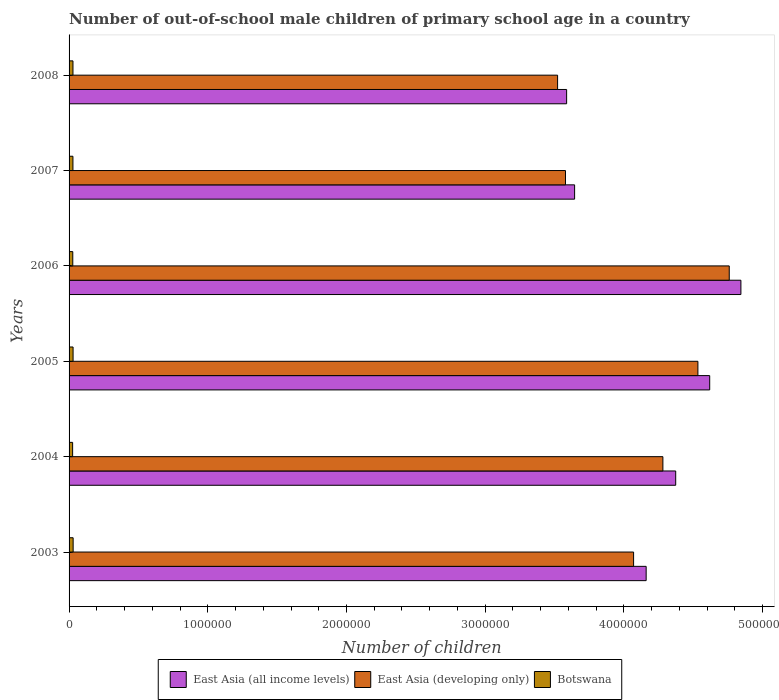How many different coloured bars are there?
Provide a succinct answer. 3. How many groups of bars are there?
Give a very brief answer. 6. Are the number of bars on each tick of the Y-axis equal?
Offer a very short reply. Yes. What is the label of the 4th group of bars from the top?
Keep it short and to the point. 2005. What is the number of out-of-school male children in Botswana in 2008?
Ensure brevity in your answer.  2.81e+04. Across all years, what is the maximum number of out-of-school male children in East Asia (all income levels)?
Your response must be concise. 4.84e+06. Across all years, what is the minimum number of out-of-school male children in East Asia (all income levels)?
Keep it short and to the point. 3.59e+06. What is the total number of out-of-school male children in Botswana in the graph?
Keep it short and to the point. 1.66e+05. What is the difference between the number of out-of-school male children in East Asia (all income levels) in 2003 and that in 2005?
Provide a succinct answer. -4.58e+05. What is the difference between the number of out-of-school male children in Botswana in 2008 and the number of out-of-school male children in East Asia (developing only) in 2003?
Your response must be concise. -4.04e+06. What is the average number of out-of-school male children in Botswana per year?
Keep it short and to the point. 2.77e+04. In the year 2008, what is the difference between the number of out-of-school male children in East Asia (developing only) and number of out-of-school male children in East Asia (all income levels)?
Make the answer very short. -6.50e+04. In how many years, is the number of out-of-school male children in East Asia (all income levels) greater than 4800000 ?
Offer a terse response. 1. What is the ratio of the number of out-of-school male children in East Asia (developing only) in 2007 to that in 2008?
Ensure brevity in your answer.  1.02. Is the number of out-of-school male children in East Asia (developing only) in 2003 less than that in 2008?
Provide a short and direct response. No. What is the difference between the highest and the second highest number of out-of-school male children in Botswana?
Offer a terse response. 468. What is the difference between the highest and the lowest number of out-of-school male children in East Asia (all income levels)?
Your response must be concise. 1.26e+06. In how many years, is the number of out-of-school male children in Botswana greater than the average number of out-of-school male children in Botswana taken over all years?
Your response must be concise. 4. What does the 2nd bar from the top in 2003 represents?
Keep it short and to the point. East Asia (developing only). What does the 2nd bar from the bottom in 2007 represents?
Provide a short and direct response. East Asia (developing only). Is it the case that in every year, the sum of the number of out-of-school male children in East Asia (developing only) and number of out-of-school male children in Botswana is greater than the number of out-of-school male children in East Asia (all income levels)?
Give a very brief answer. No. What is the difference between two consecutive major ticks on the X-axis?
Offer a very short reply. 1.00e+06. What is the title of the graph?
Your answer should be very brief. Number of out-of-school male children of primary school age in a country. What is the label or title of the X-axis?
Provide a short and direct response. Number of children. What is the Number of children of East Asia (all income levels) in 2003?
Make the answer very short. 4.16e+06. What is the Number of children of East Asia (developing only) in 2003?
Provide a short and direct response. 4.07e+06. What is the Number of children of Botswana in 2003?
Offer a terse response. 2.93e+04. What is the Number of children in East Asia (all income levels) in 2004?
Provide a short and direct response. 4.37e+06. What is the Number of children in East Asia (developing only) in 2004?
Offer a very short reply. 4.28e+06. What is the Number of children in Botswana in 2004?
Your answer should be very brief. 2.56e+04. What is the Number of children in East Asia (all income levels) in 2005?
Provide a short and direct response. 4.62e+06. What is the Number of children of East Asia (developing only) in 2005?
Provide a short and direct response. 4.53e+06. What is the Number of children in Botswana in 2005?
Your response must be concise. 2.88e+04. What is the Number of children in East Asia (all income levels) in 2006?
Make the answer very short. 4.84e+06. What is the Number of children in East Asia (developing only) in 2006?
Give a very brief answer. 4.76e+06. What is the Number of children of Botswana in 2006?
Your response must be concise. 2.67e+04. What is the Number of children of East Asia (all income levels) in 2007?
Your response must be concise. 3.64e+06. What is the Number of children of East Asia (developing only) in 2007?
Provide a succinct answer. 3.58e+06. What is the Number of children in Botswana in 2007?
Make the answer very short. 2.78e+04. What is the Number of children of East Asia (all income levels) in 2008?
Ensure brevity in your answer.  3.59e+06. What is the Number of children in East Asia (developing only) in 2008?
Provide a succinct answer. 3.52e+06. What is the Number of children in Botswana in 2008?
Offer a terse response. 2.81e+04. Across all years, what is the maximum Number of children in East Asia (all income levels)?
Give a very brief answer. 4.84e+06. Across all years, what is the maximum Number of children of East Asia (developing only)?
Make the answer very short. 4.76e+06. Across all years, what is the maximum Number of children in Botswana?
Your response must be concise. 2.93e+04. Across all years, what is the minimum Number of children of East Asia (all income levels)?
Provide a short and direct response. 3.59e+06. Across all years, what is the minimum Number of children in East Asia (developing only)?
Ensure brevity in your answer.  3.52e+06. Across all years, what is the minimum Number of children of Botswana?
Keep it short and to the point. 2.56e+04. What is the total Number of children in East Asia (all income levels) in the graph?
Your answer should be compact. 2.52e+07. What is the total Number of children of East Asia (developing only) in the graph?
Ensure brevity in your answer.  2.47e+07. What is the total Number of children of Botswana in the graph?
Offer a terse response. 1.66e+05. What is the difference between the Number of children in East Asia (all income levels) in 2003 and that in 2004?
Ensure brevity in your answer.  -2.13e+05. What is the difference between the Number of children of East Asia (developing only) in 2003 and that in 2004?
Your response must be concise. -2.11e+05. What is the difference between the Number of children in Botswana in 2003 and that in 2004?
Make the answer very short. 3717. What is the difference between the Number of children of East Asia (all income levels) in 2003 and that in 2005?
Offer a terse response. -4.58e+05. What is the difference between the Number of children of East Asia (developing only) in 2003 and that in 2005?
Give a very brief answer. -4.64e+05. What is the difference between the Number of children in Botswana in 2003 and that in 2005?
Keep it short and to the point. 468. What is the difference between the Number of children of East Asia (all income levels) in 2003 and that in 2006?
Your response must be concise. -6.83e+05. What is the difference between the Number of children of East Asia (developing only) in 2003 and that in 2006?
Offer a terse response. -6.90e+05. What is the difference between the Number of children of Botswana in 2003 and that in 2006?
Make the answer very short. 2620. What is the difference between the Number of children of East Asia (all income levels) in 2003 and that in 2007?
Keep it short and to the point. 5.16e+05. What is the difference between the Number of children of East Asia (developing only) in 2003 and that in 2007?
Your response must be concise. 4.91e+05. What is the difference between the Number of children of Botswana in 2003 and that in 2007?
Your answer should be compact. 1478. What is the difference between the Number of children in East Asia (all income levels) in 2003 and that in 2008?
Your response must be concise. 5.73e+05. What is the difference between the Number of children of East Asia (developing only) in 2003 and that in 2008?
Your answer should be very brief. 5.48e+05. What is the difference between the Number of children in Botswana in 2003 and that in 2008?
Provide a short and direct response. 1226. What is the difference between the Number of children in East Asia (all income levels) in 2004 and that in 2005?
Make the answer very short. -2.45e+05. What is the difference between the Number of children of East Asia (developing only) in 2004 and that in 2005?
Ensure brevity in your answer.  -2.53e+05. What is the difference between the Number of children in Botswana in 2004 and that in 2005?
Offer a very short reply. -3249. What is the difference between the Number of children of East Asia (all income levels) in 2004 and that in 2006?
Your response must be concise. -4.70e+05. What is the difference between the Number of children in East Asia (developing only) in 2004 and that in 2006?
Your answer should be compact. -4.78e+05. What is the difference between the Number of children in Botswana in 2004 and that in 2006?
Provide a succinct answer. -1097. What is the difference between the Number of children in East Asia (all income levels) in 2004 and that in 2007?
Give a very brief answer. 7.29e+05. What is the difference between the Number of children of East Asia (developing only) in 2004 and that in 2007?
Provide a succinct answer. 7.02e+05. What is the difference between the Number of children in Botswana in 2004 and that in 2007?
Keep it short and to the point. -2239. What is the difference between the Number of children of East Asia (all income levels) in 2004 and that in 2008?
Your answer should be compact. 7.86e+05. What is the difference between the Number of children of East Asia (developing only) in 2004 and that in 2008?
Your answer should be very brief. 7.59e+05. What is the difference between the Number of children in Botswana in 2004 and that in 2008?
Provide a succinct answer. -2491. What is the difference between the Number of children of East Asia (all income levels) in 2005 and that in 2006?
Offer a terse response. -2.25e+05. What is the difference between the Number of children of East Asia (developing only) in 2005 and that in 2006?
Your answer should be very brief. -2.26e+05. What is the difference between the Number of children of Botswana in 2005 and that in 2006?
Offer a very short reply. 2152. What is the difference between the Number of children of East Asia (all income levels) in 2005 and that in 2007?
Your answer should be very brief. 9.74e+05. What is the difference between the Number of children in East Asia (developing only) in 2005 and that in 2007?
Offer a terse response. 9.55e+05. What is the difference between the Number of children of Botswana in 2005 and that in 2007?
Provide a succinct answer. 1010. What is the difference between the Number of children in East Asia (all income levels) in 2005 and that in 2008?
Offer a very short reply. 1.03e+06. What is the difference between the Number of children in East Asia (developing only) in 2005 and that in 2008?
Provide a succinct answer. 1.01e+06. What is the difference between the Number of children of Botswana in 2005 and that in 2008?
Keep it short and to the point. 758. What is the difference between the Number of children of East Asia (all income levels) in 2006 and that in 2007?
Offer a terse response. 1.20e+06. What is the difference between the Number of children of East Asia (developing only) in 2006 and that in 2007?
Give a very brief answer. 1.18e+06. What is the difference between the Number of children in Botswana in 2006 and that in 2007?
Your response must be concise. -1142. What is the difference between the Number of children of East Asia (all income levels) in 2006 and that in 2008?
Make the answer very short. 1.26e+06. What is the difference between the Number of children of East Asia (developing only) in 2006 and that in 2008?
Provide a succinct answer. 1.24e+06. What is the difference between the Number of children in Botswana in 2006 and that in 2008?
Provide a short and direct response. -1394. What is the difference between the Number of children of East Asia (all income levels) in 2007 and that in 2008?
Offer a very short reply. 5.76e+04. What is the difference between the Number of children of East Asia (developing only) in 2007 and that in 2008?
Give a very brief answer. 5.68e+04. What is the difference between the Number of children of Botswana in 2007 and that in 2008?
Your answer should be compact. -252. What is the difference between the Number of children of East Asia (all income levels) in 2003 and the Number of children of East Asia (developing only) in 2004?
Offer a terse response. -1.21e+05. What is the difference between the Number of children of East Asia (all income levels) in 2003 and the Number of children of Botswana in 2004?
Your answer should be very brief. 4.13e+06. What is the difference between the Number of children of East Asia (developing only) in 2003 and the Number of children of Botswana in 2004?
Your answer should be very brief. 4.04e+06. What is the difference between the Number of children in East Asia (all income levels) in 2003 and the Number of children in East Asia (developing only) in 2005?
Give a very brief answer. -3.73e+05. What is the difference between the Number of children in East Asia (all income levels) in 2003 and the Number of children in Botswana in 2005?
Provide a short and direct response. 4.13e+06. What is the difference between the Number of children in East Asia (developing only) in 2003 and the Number of children in Botswana in 2005?
Ensure brevity in your answer.  4.04e+06. What is the difference between the Number of children in East Asia (all income levels) in 2003 and the Number of children in East Asia (developing only) in 2006?
Offer a terse response. -5.99e+05. What is the difference between the Number of children of East Asia (all income levels) in 2003 and the Number of children of Botswana in 2006?
Offer a very short reply. 4.13e+06. What is the difference between the Number of children of East Asia (developing only) in 2003 and the Number of children of Botswana in 2006?
Provide a succinct answer. 4.04e+06. What is the difference between the Number of children of East Asia (all income levels) in 2003 and the Number of children of East Asia (developing only) in 2007?
Provide a short and direct response. 5.82e+05. What is the difference between the Number of children of East Asia (all income levels) in 2003 and the Number of children of Botswana in 2007?
Give a very brief answer. 4.13e+06. What is the difference between the Number of children of East Asia (developing only) in 2003 and the Number of children of Botswana in 2007?
Make the answer very short. 4.04e+06. What is the difference between the Number of children in East Asia (all income levels) in 2003 and the Number of children in East Asia (developing only) in 2008?
Your response must be concise. 6.38e+05. What is the difference between the Number of children of East Asia (all income levels) in 2003 and the Number of children of Botswana in 2008?
Offer a terse response. 4.13e+06. What is the difference between the Number of children in East Asia (developing only) in 2003 and the Number of children in Botswana in 2008?
Offer a very short reply. 4.04e+06. What is the difference between the Number of children of East Asia (all income levels) in 2004 and the Number of children of East Asia (developing only) in 2005?
Your answer should be very brief. -1.60e+05. What is the difference between the Number of children in East Asia (all income levels) in 2004 and the Number of children in Botswana in 2005?
Make the answer very short. 4.34e+06. What is the difference between the Number of children of East Asia (developing only) in 2004 and the Number of children of Botswana in 2005?
Offer a terse response. 4.25e+06. What is the difference between the Number of children in East Asia (all income levels) in 2004 and the Number of children in East Asia (developing only) in 2006?
Your answer should be compact. -3.86e+05. What is the difference between the Number of children of East Asia (all income levels) in 2004 and the Number of children of Botswana in 2006?
Ensure brevity in your answer.  4.35e+06. What is the difference between the Number of children in East Asia (developing only) in 2004 and the Number of children in Botswana in 2006?
Provide a short and direct response. 4.25e+06. What is the difference between the Number of children of East Asia (all income levels) in 2004 and the Number of children of East Asia (developing only) in 2007?
Your answer should be compact. 7.95e+05. What is the difference between the Number of children in East Asia (all income levels) in 2004 and the Number of children in Botswana in 2007?
Your response must be concise. 4.35e+06. What is the difference between the Number of children of East Asia (developing only) in 2004 and the Number of children of Botswana in 2007?
Offer a terse response. 4.25e+06. What is the difference between the Number of children in East Asia (all income levels) in 2004 and the Number of children in East Asia (developing only) in 2008?
Offer a very short reply. 8.51e+05. What is the difference between the Number of children of East Asia (all income levels) in 2004 and the Number of children of Botswana in 2008?
Give a very brief answer. 4.35e+06. What is the difference between the Number of children in East Asia (developing only) in 2004 and the Number of children in Botswana in 2008?
Make the answer very short. 4.25e+06. What is the difference between the Number of children in East Asia (all income levels) in 2005 and the Number of children in East Asia (developing only) in 2006?
Your answer should be compact. -1.41e+05. What is the difference between the Number of children in East Asia (all income levels) in 2005 and the Number of children in Botswana in 2006?
Your answer should be very brief. 4.59e+06. What is the difference between the Number of children of East Asia (developing only) in 2005 and the Number of children of Botswana in 2006?
Provide a short and direct response. 4.51e+06. What is the difference between the Number of children in East Asia (all income levels) in 2005 and the Number of children in East Asia (developing only) in 2007?
Give a very brief answer. 1.04e+06. What is the difference between the Number of children of East Asia (all income levels) in 2005 and the Number of children of Botswana in 2007?
Make the answer very short. 4.59e+06. What is the difference between the Number of children in East Asia (developing only) in 2005 and the Number of children in Botswana in 2007?
Your response must be concise. 4.51e+06. What is the difference between the Number of children of East Asia (all income levels) in 2005 and the Number of children of East Asia (developing only) in 2008?
Ensure brevity in your answer.  1.10e+06. What is the difference between the Number of children of East Asia (all income levels) in 2005 and the Number of children of Botswana in 2008?
Provide a short and direct response. 4.59e+06. What is the difference between the Number of children in East Asia (developing only) in 2005 and the Number of children in Botswana in 2008?
Your answer should be very brief. 4.51e+06. What is the difference between the Number of children in East Asia (all income levels) in 2006 and the Number of children in East Asia (developing only) in 2007?
Offer a terse response. 1.26e+06. What is the difference between the Number of children of East Asia (all income levels) in 2006 and the Number of children of Botswana in 2007?
Provide a succinct answer. 4.82e+06. What is the difference between the Number of children of East Asia (developing only) in 2006 and the Number of children of Botswana in 2007?
Offer a terse response. 4.73e+06. What is the difference between the Number of children in East Asia (all income levels) in 2006 and the Number of children in East Asia (developing only) in 2008?
Provide a short and direct response. 1.32e+06. What is the difference between the Number of children of East Asia (all income levels) in 2006 and the Number of children of Botswana in 2008?
Your answer should be very brief. 4.82e+06. What is the difference between the Number of children of East Asia (developing only) in 2006 and the Number of children of Botswana in 2008?
Offer a very short reply. 4.73e+06. What is the difference between the Number of children of East Asia (all income levels) in 2007 and the Number of children of East Asia (developing only) in 2008?
Your answer should be compact. 1.23e+05. What is the difference between the Number of children of East Asia (all income levels) in 2007 and the Number of children of Botswana in 2008?
Ensure brevity in your answer.  3.62e+06. What is the difference between the Number of children of East Asia (developing only) in 2007 and the Number of children of Botswana in 2008?
Your response must be concise. 3.55e+06. What is the average Number of children in East Asia (all income levels) per year?
Give a very brief answer. 4.20e+06. What is the average Number of children of East Asia (developing only) per year?
Ensure brevity in your answer.  4.12e+06. What is the average Number of children of Botswana per year?
Give a very brief answer. 2.77e+04. In the year 2003, what is the difference between the Number of children in East Asia (all income levels) and Number of children in East Asia (developing only)?
Make the answer very short. 9.06e+04. In the year 2003, what is the difference between the Number of children of East Asia (all income levels) and Number of children of Botswana?
Offer a very short reply. 4.13e+06. In the year 2003, what is the difference between the Number of children of East Asia (developing only) and Number of children of Botswana?
Offer a terse response. 4.04e+06. In the year 2004, what is the difference between the Number of children of East Asia (all income levels) and Number of children of East Asia (developing only)?
Offer a terse response. 9.24e+04. In the year 2004, what is the difference between the Number of children of East Asia (all income levels) and Number of children of Botswana?
Your answer should be very brief. 4.35e+06. In the year 2004, what is the difference between the Number of children in East Asia (developing only) and Number of children in Botswana?
Offer a terse response. 4.26e+06. In the year 2005, what is the difference between the Number of children in East Asia (all income levels) and Number of children in East Asia (developing only)?
Your answer should be very brief. 8.50e+04. In the year 2005, what is the difference between the Number of children in East Asia (all income levels) and Number of children in Botswana?
Offer a very short reply. 4.59e+06. In the year 2005, what is the difference between the Number of children in East Asia (developing only) and Number of children in Botswana?
Provide a short and direct response. 4.50e+06. In the year 2006, what is the difference between the Number of children of East Asia (all income levels) and Number of children of East Asia (developing only)?
Offer a terse response. 8.40e+04. In the year 2006, what is the difference between the Number of children of East Asia (all income levels) and Number of children of Botswana?
Provide a short and direct response. 4.82e+06. In the year 2006, what is the difference between the Number of children in East Asia (developing only) and Number of children in Botswana?
Provide a short and direct response. 4.73e+06. In the year 2007, what is the difference between the Number of children in East Asia (all income levels) and Number of children in East Asia (developing only)?
Make the answer very short. 6.58e+04. In the year 2007, what is the difference between the Number of children in East Asia (all income levels) and Number of children in Botswana?
Your answer should be compact. 3.62e+06. In the year 2007, what is the difference between the Number of children in East Asia (developing only) and Number of children in Botswana?
Ensure brevity in your answer.  3.55e+06. In the year 2008, what is the difference between the Number of children of East Asia (all income levels) and Number of children of East Asia (developing only)?
Give a very brief answer. 6.50e+04. In the year 2008, what is the difference between the Number of children of East Asia (all income levels) and Number of children of Botswana?
Your response must be concise. 3.56e+06. In the year 2008, what is the difference between the Number of children of East Asia (developing only) and Number of children of Botswana?
Keep it short and to the point. 3.49e+06. What is the ratio of the Number of children in East Asia (all income levels) in 2003 to that in 2004?
Offer a terse response. 0.95. What is the ratio of the Number of children of East Asia (developing only) in 2003 to that in 2004?
Provide a succinct answer. 0.95. What is the ratio of the Number of children in Botswana in 2003 to that in 2004?
Offer a terse response. 1.15. What is the ratio of the Number of children of East Asia (all income levels) in 2003 to that in 2005?
Your answer should be compact. 0.9. What is the ratio of the Number of children of East Asia (developing only) in 2003 to that in 2005?
Keep it short and to the point. 0.9. What is the ratio of the Number of children in Botswana in 2003 to that in 2005?
Your response must be concise. 1.02. What is the ratio of the Number of children in East Asia (all income levels) in 2003 to that in 2006?
Make the answer very short. 0.86. What is the ratio of the Number of children in East Asia (developing only) in 2003 to that in 2006?
Provide a short and direct response. 0.86. What is the ratio of the Number of children in Botswana in 2003 to that in 2006?
Your response must be concise. 1.1. What is the ratio of the Number of children in East Asia (all income levels) in 2003 to that in 2007?
Provide a succinct answer. 1.14. What is the ratio of the Number of children of East Asia (developing only) in 2003 to that in 2007?
Provide a succinct answer. 1.14. What is the ratio of the Number of children of Botswana in 2003 to that in 2007?
Provide a succinct answer. 1.05. What is the ratio of the Number of children in East Asia (all income levels) in 2003 to that in 2008?
Provide a succinct answer. 1.16. What is the ratio of the Number of children of East Asia (developing only) in 2003 to that in 2008?
Make the answer very short. 1.16. What is the ratio of the Number of children in Botswana in 2003 to that in 2008?
Offer a very short reply. 1.04. What is the ratio of the Number of children in East Asia (all income levels) in 2004 to that in 2005?
Your response must be concise. 0.95. What is the ratio of the Number of children of East Asia (developing only) in 2004 to that in 2005?
Ensure brevity in your answer.  0.94. What is the ratio of the Number of children of Botswana in 2004 to that in 2005?
Your response must be concise. 0.89. What is the ratio of the Number of children in East Asia (all income levels) in 2004 to that in 2006?
Offer a very short reply. 0.9. What is the ratio of the Number of children in East Asia (developing only) in 2004 to that in 2006?
Your response must be concise. 0.9. What is the ratio of the Number of children of Botswana in 2004 to that in 2006?
Make the answer very short. 0.96. What is the ratio of the Number of children in East Asia (developing only) in 2004 to that in 2007?
Offer a very short reply. 1.2. What is the ratio of the Number of children in Botswana in 2004 to that in 2007?
Your answer should be compact. 0.92. What is the ratio of the Number of children in East Asia (all income levels) in 2004 to that in 2008?
Offer a very short reply. 1.22. What is the ratio of the Number of children of East Asia (developing only) in 2004 to that in 2008?
Ensure brevity in your answer.  1.22. What is the ratio of the Number of children in Botswana in 2004 to that in 2008?
Your answer should be compact. 0.91. What is the ratio of the Number of children of East Asia (all income levels) in 2005 to that in 2006?
Keep it short and to the point. 0.95. What is the ratio of the Number of children in East Asia (developing only) in 2005 to that in 2006?
Provide a short and direct response. 0.95. What is the ratio of the Number of children in Botswana in 2005 to that in 2006?
Keep it short and to the point. 1.08. What is the ratio of the Number of children of East Asia (all income levels) in 2005 to that in 2007?
Ensure brevity in your answer.  1.27. What is the ratio of the Number of children in East Asia (developing only) in 2005 to that in 2007?
Keep it short and to the point. 1.27. What is the ratio of the Number of children in Botswana in 2005 to that in 2007?
Your response must be concise. 1.04. What is the ratio of the Number of children of East Asia (all income levels) in 2005 to that in 2008?
Make the answer very short. 1.29. What is the ratio of the Number of children in East Asia (developing only) in 2005 to that in 2008?
Provide a succinct answer. 1.29. What is the ratio of the Number of children of Botswana in 2005 to that in 2008?
Provide a short and direct response. 1.03. What is the ratio of the Number of children of East Asia (all income levels) in 2006 to that in 2007?
Provide a short and direct response. 1.33. What is the ratio of the Number of children in East Asia (developing only) in 2006 to that in 2007?
Offer a terse response. 1.33. What is the ratio of the Number of children in Botswana in 2006 to that in 2007?
Keep it short and to the point. 0.96. What is the ratio of the Number of children in East Asia (all income levels) in 2006 to that in 2008?
Your answer should be very brief. 1.35. What is the ratio of the Number of children of East Asia (developing only) in 2006 to that in 2008?
Provide a short and direct response. 1.35. What is the ratio of the Number of children of Botswana in 2006 to that in 2008?
Your answer should be compact. 0.95. What is the ratio of the Number of children of East Asia (all income levels) in 2007 to that in 2008?
Ensure brevity in your answer.  1.02. What is the ratio of the Number of children of East Asia (developing only) in 2007 to that in 2008?
Your response must be concise. 1.02. What is the ratio of the Number of children of Botswana in 2007 to that in 2008?
Offer a very short reply. 0.99. What is the difference between the highest and the second highest Number of children in East Asia (all income levels)?
Your answer should be very brief. 2.25e+05. What is the difference between the highest and the second highest Number of children of East Asia (developing only)?
Your answer should be compact. 2.26e+05. What is the difference between the highest and the second highest Number of children of Botswana?
Provide a succinct answer. 468. What is the difference between the highest and the lowest Number of children of East Asia (all income levels)?
Give a very brief answer. 1.26e+06. What is the difference between the highest and the lowest Number of children in East Asia (developing only)?
Offer a very short reply. 1.24e+06. What is the difference between the highest and the lowest Number of children in Botswana?
Ensure brevity in your answer.  3717. 